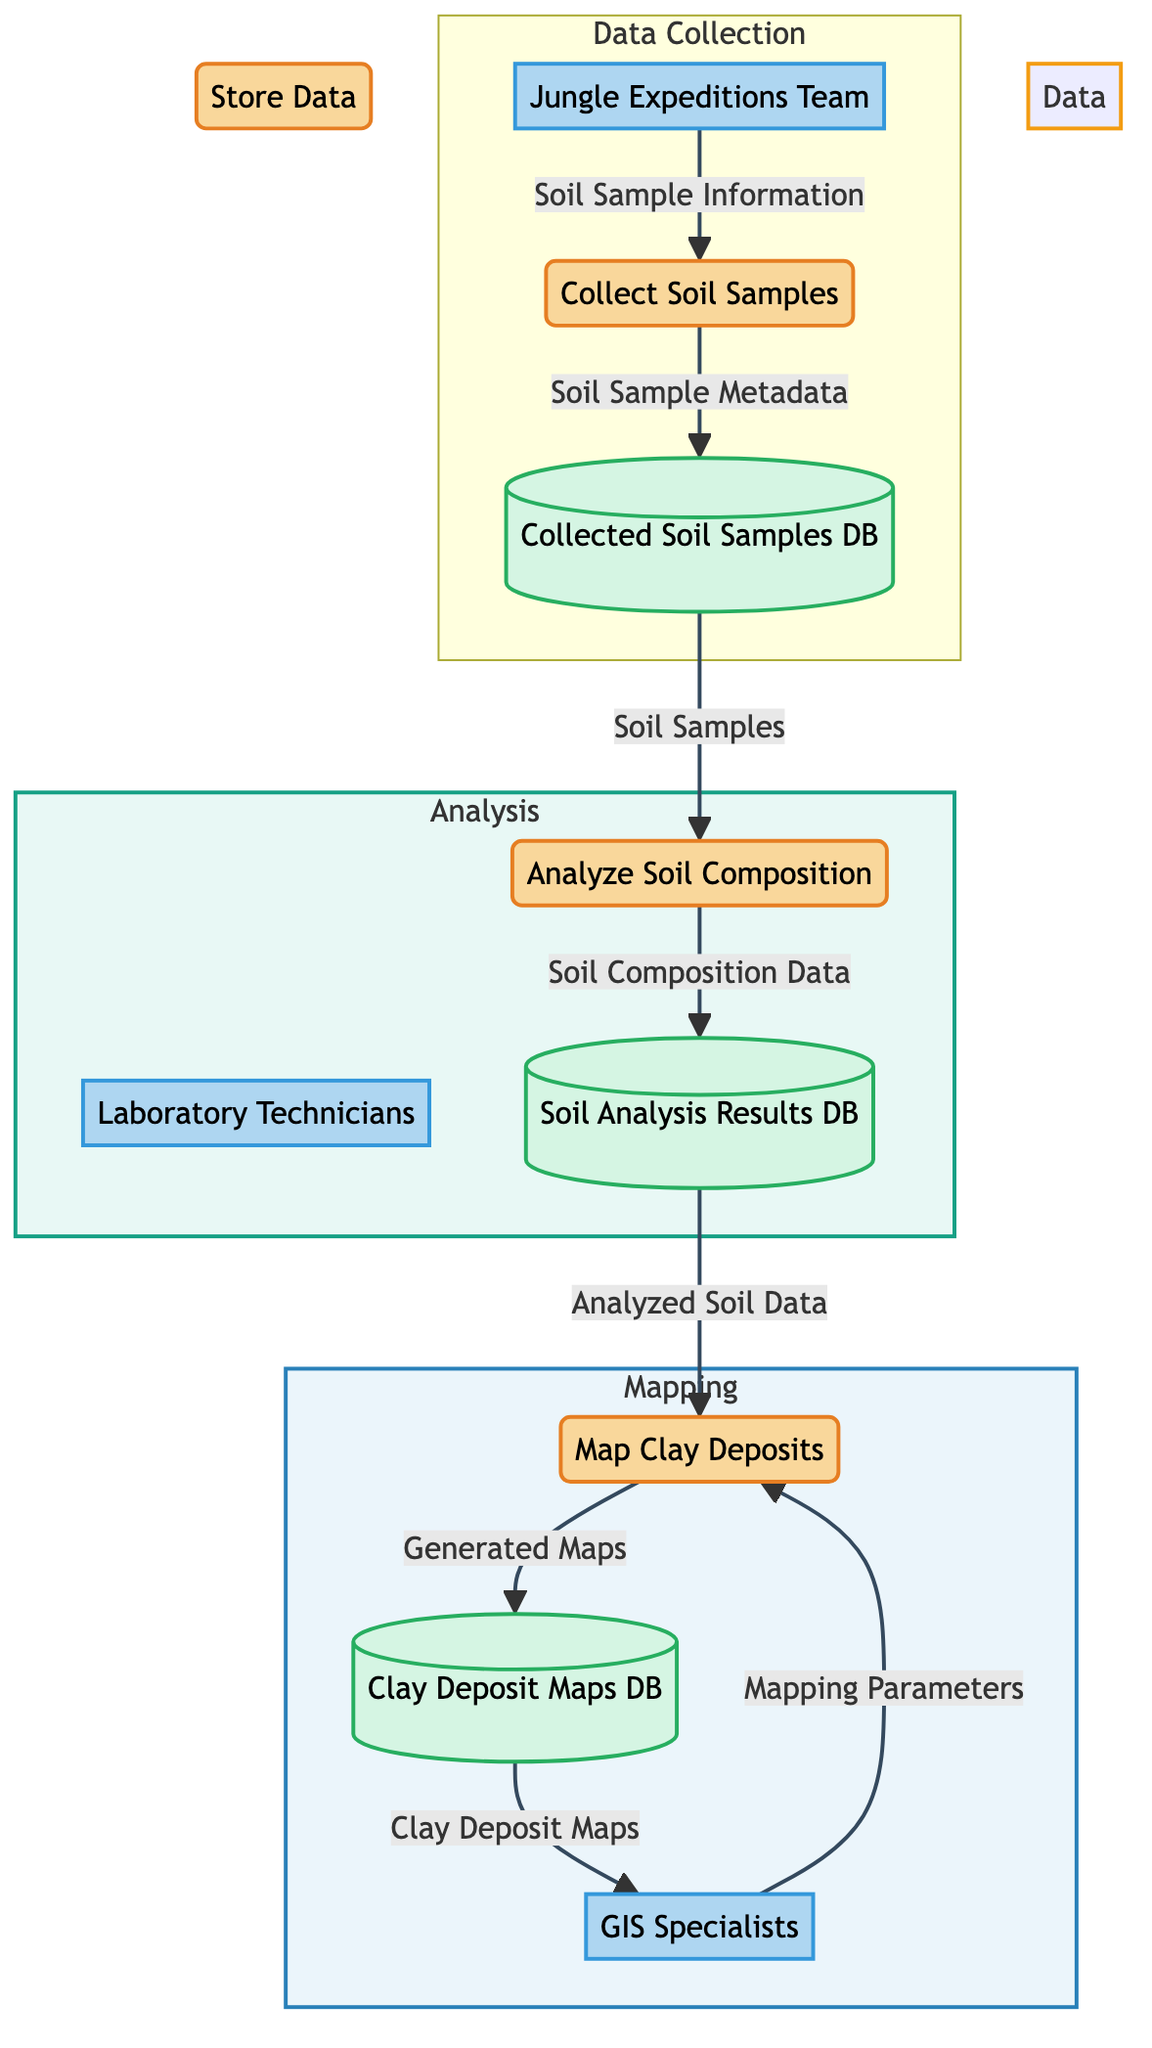What is the first process in the diagram? The first process in the diagram is labeled as "1" and is named "Collect Soil Samples." It is the initial step in the flow of the Jungle Clay Deposit Mapping System.
Answer: Collect Soil Samples How many external entities are represented in the diagram? The diagram lists three external entities: "Jungle Expeditions Team," "Laboratory Technicians," and "GIS Specialists." Therefore, the count is three.
Answer: Three What data flows from the "Analyze Soil Composition" process? The data flow from the "Analyze Soil Composition" process is labeled as "Soil Composition Data," which is delivered to the "Soil Analysis Results Database."
Answer: Soil Composition Data Who provides the "Mapping Parameters" for the mapping process? The "Mapping Parameters" are supplied by "GIS Specialists," as indicated in the directed line leading to the "Map Clay Deposits" process.
Answer: GIS Specialists Which database stores the results of soil composition analysis? The database that stores the results of soil composition analysis is labeled as "Soil Analysis Results Database." This can be traced through the flow from the "Analyze Soil Composition" process.
Answer: Soil Analysis Results Database How do "Laboratory Technicians" interact with the system? "Laboratory Technicians" are involved in the "Analyze Soil Composition" process, providing their expertise to analyze the soil samples and indirectly connect to the "Soil Analysis Results Database."
Answer: Analyze Soil Composition What is the final output stored in the database? The final output stored in the database is referred to as "Generated Maps," which are stored in the "Clay Deposit Maps Database" after the mapping process is completed.
Answer: Generated Maps What process follows the "Collect Soil Samples"? The process that follows "Collect Soil Samples" is "Analyze Soil Composition," as indicated by the direct data flow from the sampling process to the analysis step.
Answer: Analyze Soil Composition What links the "Soil Analysis Results Database" to the "Map Clay Deposits" process? The link is made through the "Analyzed Soil Data," which flows from the "Soil Analysis Results Database" to serve as input for the "Map Clay Deposits" process.
Answer: Analyzed Soil Data 